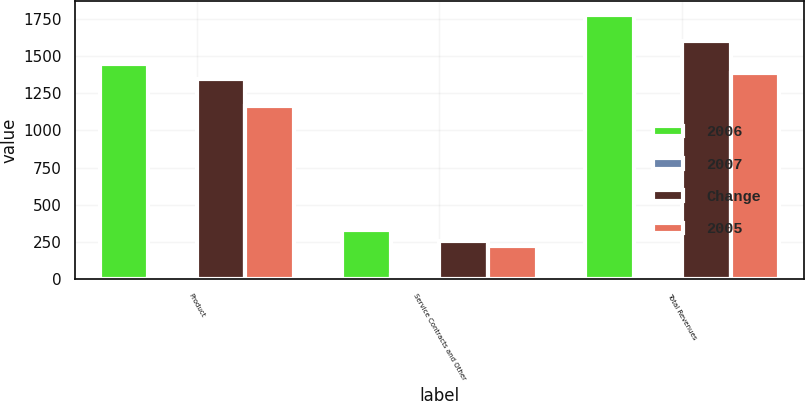Convert chart. <chart><loc_0><loc_0><loc_500><loc_500><stacked_bar_chart><ecel><fcel>Product<fcel>Service Contracts and Other<fcel>Total Revenues<nl><fcel>2006<fcel>1448<fcel>329<fcel>1777<nl><fcel>2007<fcel>8<fcel>29<fcel>11<nl><fcel>Change<fcel>1342<fcel>256<fcel>1598<nl><fcel>2005<fcel>1162<fcel>221<fcel>1383<nl></chart> 